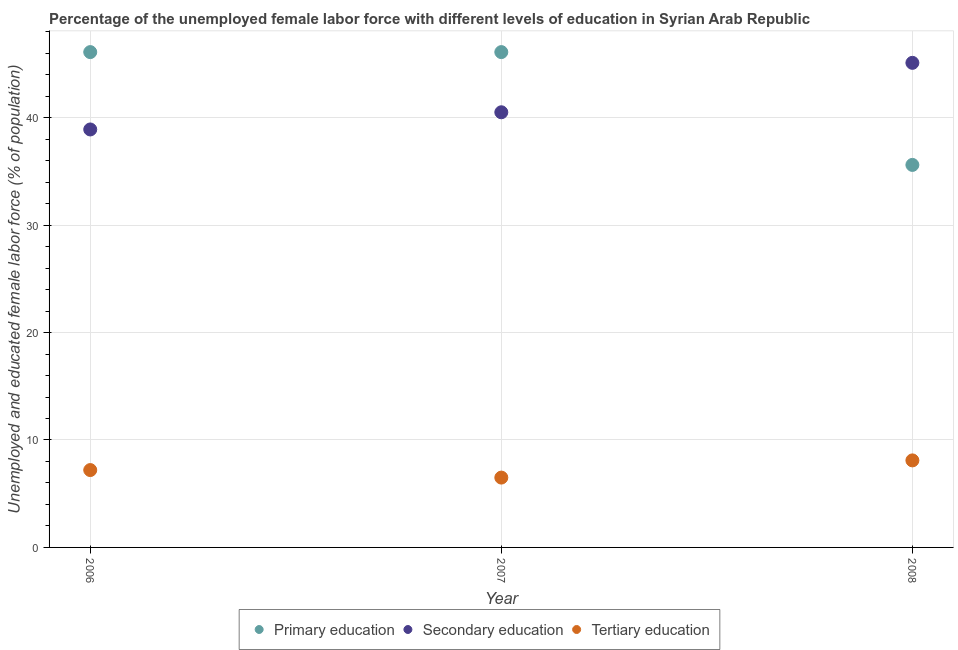Across all years, what is the maximum percentage of female labor force who received primary education?
Offer a very short reply. 46.1. Across all years, what is the minimum percentage of female labor force who received secondary education?
Make the answer very short. 38.9. In which year was the percentage of female labor force who received secondary education maximum?
Your answer should be compact. 2008. What is the total percentage of female labor force who received tertiary education in the graph?
Your response must be concise. 21.8. What is the difference between the percentage of female labor force who received primary education in 2007 and the percentage of female labor force who received secondary education in 2006?
Provide a succinct answer. 7.2. What is the average percentage of female labor force who received primary education per year?
Offer a very short reply. 42.6. In the year 2008, what is the difference between the percentage of female labor force who received primary education and percentage of female labor force who received tertiary education?
Your answer should be very brief. 27.5. In how many years, is the percentage of female labor force who received tertiary education greater than 30 %?
Provide a succinct answer. 0. What is the ratio of the percentage of female labor force who received secondary education in 2007 to that in 2008?
Offer a very short reply. 0.9. Is the percentage of female labor force who received secondary education in 2007 less than that in 2008?
Provide a short and direct response. Yes. Is the difference between the percentage of female labor force who received secondary education in 2006 and 2007 greater than the difference between the percentage of female labor force who received tertiary education in 2006 and 2007?
Your response must be concise. No. What is the difference between the highest and the second highest percentage of female labor force who received secondary education?
Your response must be concise. 4.6. What is the difference between the highest and the lowest percentage of female labor force who received secondary education?
Offer a very short reply. 6.2. In how many years, is the percentage of female labor force who received secondary education greater than the average percentage of female labor force who received secondary education taken over all years?
Ensure brevity in your answer.  1. Is it the case that in every year, the sum of the percentage of female labor force who received primary education and percentage of female labor force who received secondary education is greater than the percentage of female labor force who received tertiary education?
Provide a short and direct response. Yes. Is the percentage of female labor force who received secondary education strictly less than the percentage of female labor force who received primary education over the years?
Keep it short and to the point. No. Where does the legend appear in the graph?
Keep it short and to the point. Bottom center. What is the title of the graph?
Offer a terse response. Percentage of the unemployed female labor force with different levels of education in Syrian Arab Republic. What is the label or title of the X-axis?
Offer a terse response. Year. What is the label or title of the Y-axis?
Offer a very short reply. Unemployed and educated female labor force (% of population). What is the Unemployed and educated female labor force (% of population) in Primary education in 2006?
Your answer should be compact. 46.1. What is the Unemployed and educated female labor force (% of population) of Secondary education in 2006?
Provide a short and direct response. 38.9. What is the Unemployed and educated female labor force (% of population) of Tertiary education in 2006?
Make the answer very short. 7.2. What is the Unemployed and educated female labor force (% of population) in Primary education in 2007?
Provide a short and direct response. 46.1. What is the Unemployed and educated female labor force (% of population) of Secondary education in 2007?
Your answer should be very brief. 40.5. What is the Unemployed and educated female labor force (% of population) in Primary education in 2008?
Give a very brief answer. 35.6. What is the Unemployed and educated female labor force (% of population) in Secondary education in 2008?
Offer a terse response. 45.1. What is the Unemployed and educated female labor force (% of population) in Tertiary education in 2008?
Give a very brief answer. 8.1. Across all years, what is the maximum Unemployed and educated female labor force (% of population) of Primary education?
Make the answer very short. 46.1. Across all years, what is the maximum Unemployed and educated female labor force (% of population) of Secondary education?
Provide a succinct answer. 45.1. Across all years, what is the maximum Unemployed and educated female labor force (% of population) in Tertiary education?
Offer a very short reply. 8.1. Across all years, what is the minimum Unemployed and educated female labor force (% of population) in Primary education?
Your answer should be very brief. 35.6. Across all years, what is the minimum Unemployed and educated female labor force (% of population) in Secondary education?
Your answer should be compact. 38.9. What is the total Unemployed and educated female labor force (% of population) in Primary education in the graph?
Provide a succinct answer. 127.8. What is the total Unemployed and educated female labor force (% of population) in Secondary education in the graph?
Give a very brief answer. 124.5. What is the total Unemployed and educated female labor force (% of population) of Tertiary education in the graph?
Keep it short and to the point. 21.8. What is the difference between the Unemployed and educated female labor force (% of population) in Primary education in 2006 and that in 2007?
Make the answer very short. 0. What is the difference between the Unemployed and educated female labor force (% of population) in Tertiary education in 2006 and that in 2007?
Your answer should be compact. 0.7. What is the difference between the Unemployed and educated female labor force (% of population) in Primary education in 2006 and that in 2008?
Offer a terse response. 10.5. What is the difference between the Unemployed and educated female labor force (% of population) of Tertiary education in 2006 and that in 2008?
Offer a very short reply. -0.9. What is the difference between the Unemployed and educated female labor force (% of population) of Tertiary education in 2007 and that in 2008?
Give a very brief answer. -1.6. What is the difference between the Unemployed and educated female labor force (% of population) of Primary education in 2006 and the Unemployed and educated female labor force (% of population) of Secondary education in 2007?
Your answer should be compact. 5.6. What is the difference between the Unemployed and educated female labor force (% of population) in Primary education in 2006 and the Unemployed and educated female labor force (% of population) in Tertiary education in 2007?
Make the answer very short. 39.6. What is the difference between the Unemployed and educated female labor force (% of population) in Secondary education in 2006 and the Unemployed and educated female labor force (% of population) in Tertiary education in 2007?
Offer a terse response. 32.4. What is the difference between the Unemployed and educated female labor force (% of population) in Primary education in 2006 and the Unemployed and educated female labor force (% of population) in Secondary education in 2008?
Give a very brief answer. 1. What is the difference between the Unemployed and educated female labor force (% of population) of Primary education in 2006 and the Unemployed and educated female labor force (% of population) of Tertiary education in 2008?
Provide a succinct answer. 38. What is the difference between the Unemployed and educated female labor force (% of population) of Secondary education in 2006 and the Unemployed and educated female labor force (% of population) of Tertiary education in 2008?
Make the answer very short. 30.8. What is the difference between the Unemployed and educated female labor force (% of population) in Secondary education in 2007 and the Unemployed and educated female labor force (% of population) in Tertiary education in 2008?
Your response must be concise. 32.4. What is the average Unemployed and educated female labor force (% of population) of Primary education per year?
Your answer should be very brief. 42.6. What is the average Unemployed and educated female labor force (% of population) of Secondary education per year?
Provide a short and direct response. 41.5. What is the average Unemployed and educated female labor force (% of population) in Tertiary education per year?
Keep it short and to the point. 7.27. In the year 2006, what is the difference between the Unemployed and educated female labor force (% of population) of Primary education and Unemployed and educated female labor force (% of population) of Secondary education?
Give a very brief answer. 7.2. In the year 2006, what is the difference between the Unemployed and educated female labor force (% of population) of Primary education and Unemployed and educated female labor force (% of population) of Tertiary education?
Offer a terse response. 38.9. In the year 2006, what is the difference between the Unemployed and educated female labor force (% of population) of Secondary education and Unemployed and educated female labor force (% of population) of Tertiary education?
Your response must be concise. 31.7. In the year 2007, what is the difference between the Unemployed and educated female labor force (% of population) of Primary education and Unemployed and educated female labor force (% of population) of Secondary education?
Make the answer very short. 5.6. In the year 2007, what is the difference between the Unemployed and educated female labor force (% of population) of Primary education and Unemployed and educated female labor force (% of population) of Tertiary education?
Give a very brief answer. 39.6. In the year 2007, what is the difference between the Unemployed and educated female labor force (% of population) in Secondary education and Unemployed and educated female labor force (% of population) in Tertiary education?
Provide a succinct answer. 34. In the year 2008, what is the difference between the Unemployed and educated female labor force (% of population) in Secondary education and Unemployed and educated female labor force (% of population) in Tertiary education?
Provide a succinct answer. 37. What is the ratio of the Unemployed and educated female labor force (% of population) of Secondary education in 2006 to that in 2007?
Give a very brief answer. 0.96. What is the ratio of the Unemployed and educated female labor force (% of population) in Tertiary education in 2006 to that in 2007?
Keep it short and to the point. 1.11. What is the ratio of the Unemployed and educated female labor force (% of population) in Primary education in 2006 to that in 2008?
Make the answer very short. 1.29. What is the ratio of the Unemployed and educated female labor force (% of population) of Secondary education in 2006 to that in 2008?
Your response must be concise. 0.86. What is the ratio of the Unemployed and educated female labor force (% of population) in Primary education in 2007 to that in 2008?
Provide a succinct answer. 1.29. What is the ratio of the Unemployed and educated female labor force (% of population) in Secondary education in 2007 to that in 2008?
Your answer should be compact. 0.9. What is the ratio of the Unemployed and educated female labor force (% of population) of Tertiary education in 2007 to that in 2008?
Offer a very short reply. 0.8. What is the difference between the highest and the second highest Unemployed and educated female labor force (% of population) of Primary education?
Ensure brevity in your answer.  0. 